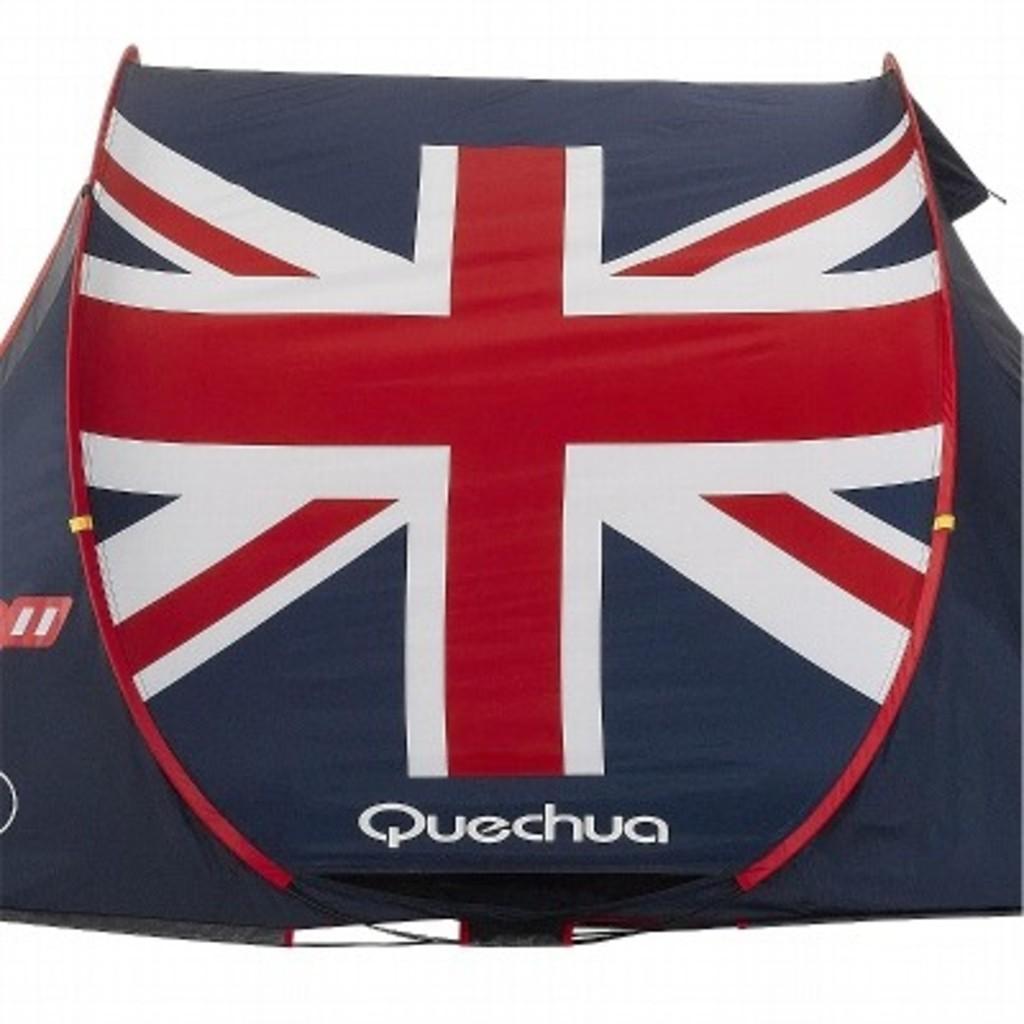In one or two sentences, can you explain what this image depicts? In this image I can see black colour thing and on it I can see red and white colour lines. I can also see something is written over here and I can see white colour in background. 